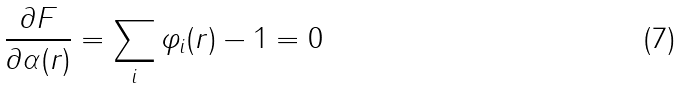<formula> <loc_0><loc_0><loc_500><loc_500>\frac { \partial F } { \partial \alpha ( r ) } = \sum _ { i } \varphi _ { i } ( r ) - 1 = 0</formula> 